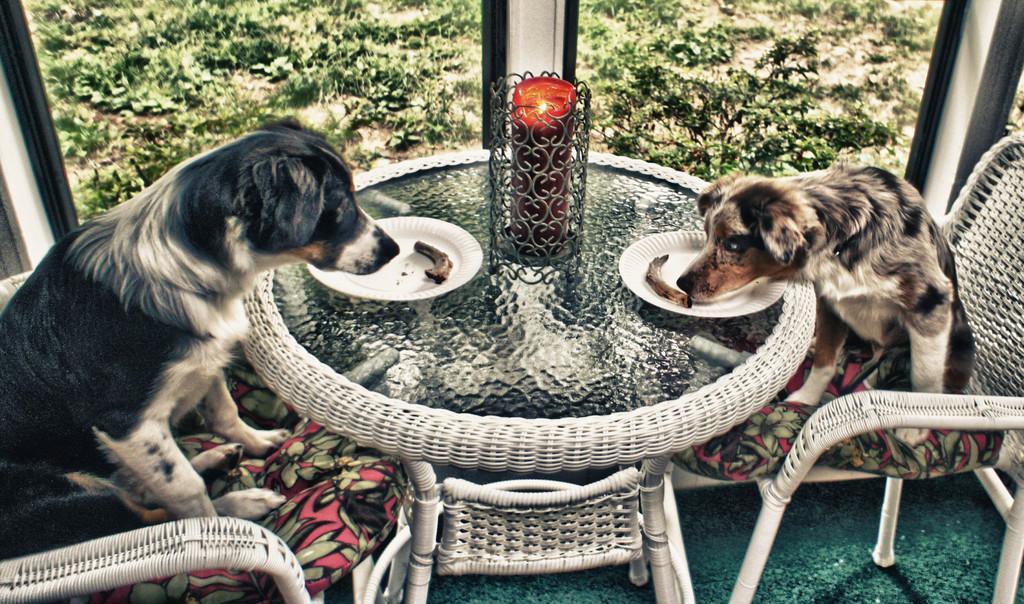Can you describe this image briefly? As we can see in the image there are trees, chairs and a table. On table there are plates, candle and two dogs. 